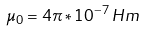Convert formula to latex. <formula><loc_0><loc_0><loc_500><loc_500>\mu _ { 0 } = 4 \pi * 1 0 ^ { - 7 } \, H m</formula> 